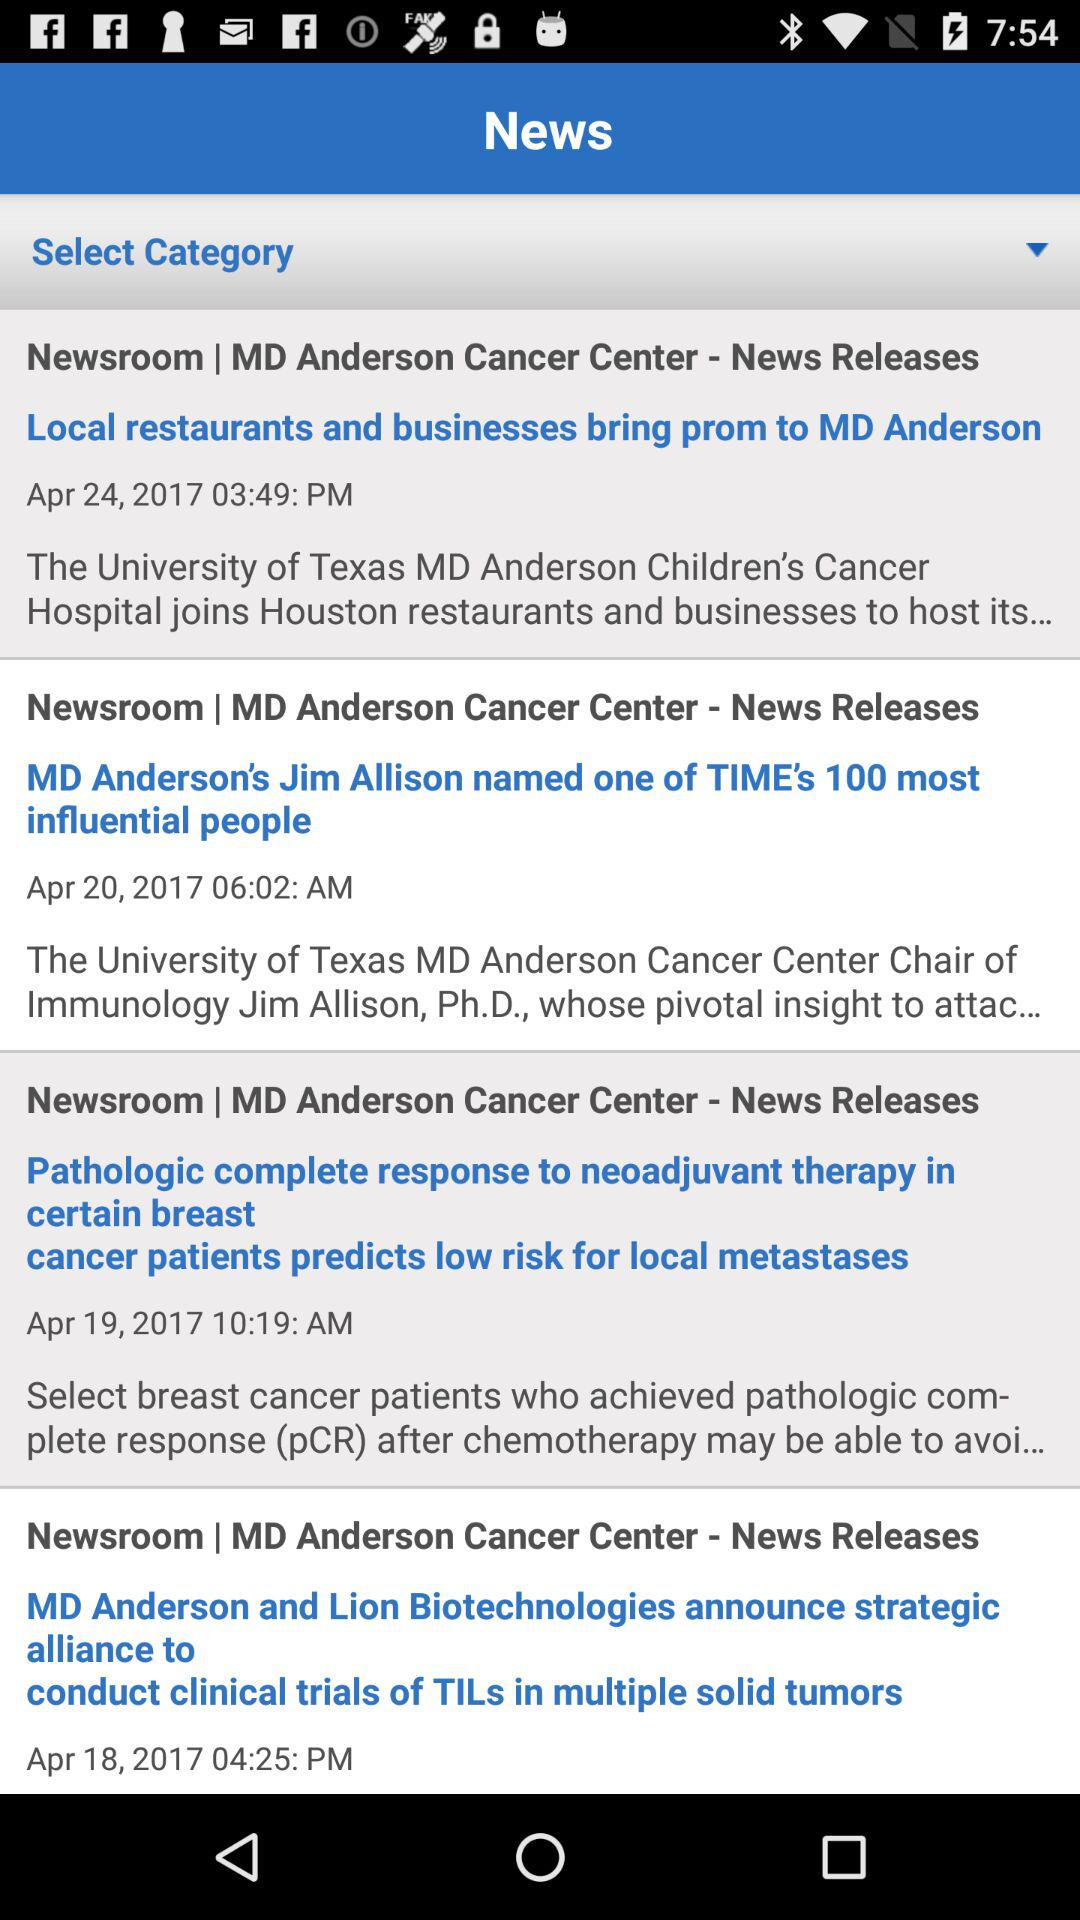What is the date of the news "MD Anderson's Jim Allison named one of TIME's 100 most influential people"? The date is April 20, 2017. 